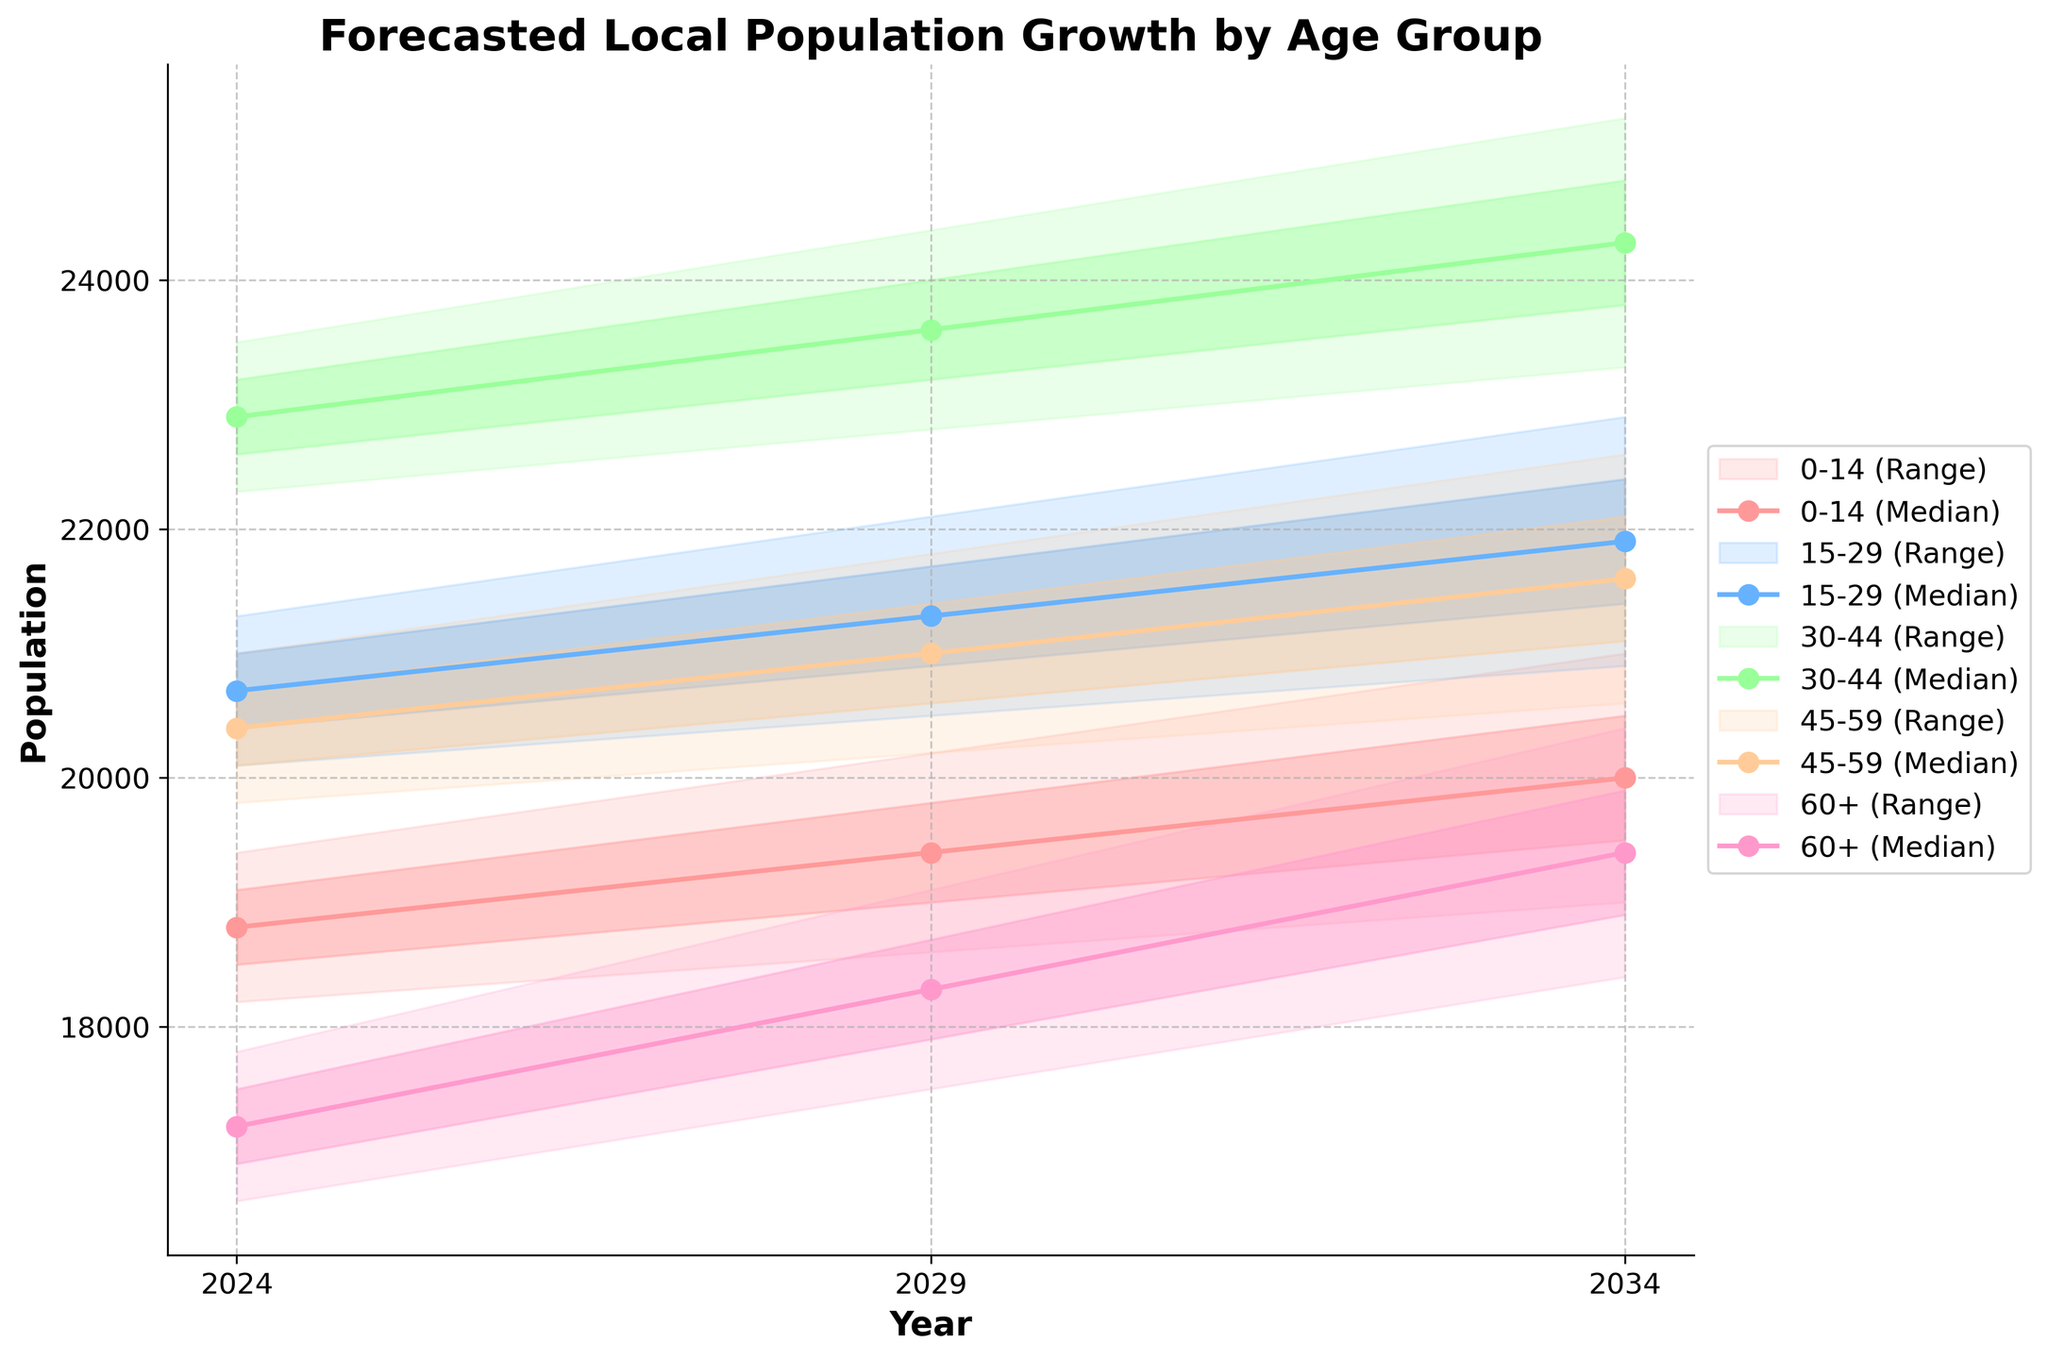What is the title of the figure? The title of the figure is located at the top, showing a brief description of what the chart represents. It reads "Forecasted Local Population Growth by Age Group".
Answer: Forecasted Local Population Growth by Age Group What does the x-axis represent in the chart? The x-axis represents the years for which the population growth is forecasted, specifically 2024, 2029, and 2034.
Answer: Years Which age group has the highest upper bound in the year 2024? Look at the year 2024 and compare the upper boundaries of each age group. The age group 30-44 has the highest upper bound value of 23500.
Answer: 30-44 What is the median population for the 15-29 age group in 2029? Locate the 15-29 age group for the year 2029 and identify the median value plotted. The median is 21300.
Answer: 21300 Between which years does the population for the 60+ age group increase the most in terms of median value? Compare the median values for the 60+ age group between 2024 and 2029, and then between 2029 and 2034. The increase between 2029 (18300) and 2034 (19400) is 1100, which is higher than the increase from 2024 (17200) to 2029 (18300), which is 1100.
Answer: 2029 to 2034 Which age group shows the smallest range (difference between upper and lower bounds) in 2034? For each age group in 2034, subtract the lower bound from the upper bound and compare the differences. The smallest range is for the 0-14 age group: 21000 - 19000 = 2000.
Answer: 0-14 How does the population trend for the 45-59 age group change from 2024 to 2034 in terms of the 75th percentile values? Compare the 75th percentile values for the 45-59 age group over the years. From 2024 (20700) to 2029 (21400), an increase of 700. From 2029 to 2034 (22100), an increase of 700. Overall, there is an increase from 20700 in 2024 to 22100 in 2034, showing a rising trend.
Answer: Increases steadily What is the percentage increase in the median population for the 30-44 age group from 2024 to 2034? Calculate the percentage increase from 2024 (22900) to 2034 (24300). The increase is (24300 - 22900) = 1400. Percentage increase is (1400 / 22900) * 100 ≈ 6.11%.
Answer: 6.11% Which age group has the widest interquartile range (difference between 75th and 25th percentile) in 2029? Find the difference between the 75th and 25th percentile values for each age group in 2029 and identify the widest range. For instance, for 0-14 group: 19800 - 19000 = 800. 15-29: 21700 - 20900 = 800. 30-44: 24000 - 23200 = 800. 45-59: 21400 - 20600 = 800. 60+: 18700 - 17900 = 800. The widest interquartile range is observed in the 30-44 age group, equal to 800.
Answer: 30-44 Which age group shows the most consistent population growth trend based on the median line from 2024 to 2034? Examine the median lines for each age group from 2024 to 2034. Consistency implies a smooth, steady increase. The 15-29 age group shows a consistently increasing trend without major fluctuations.
Answer: 15-29 